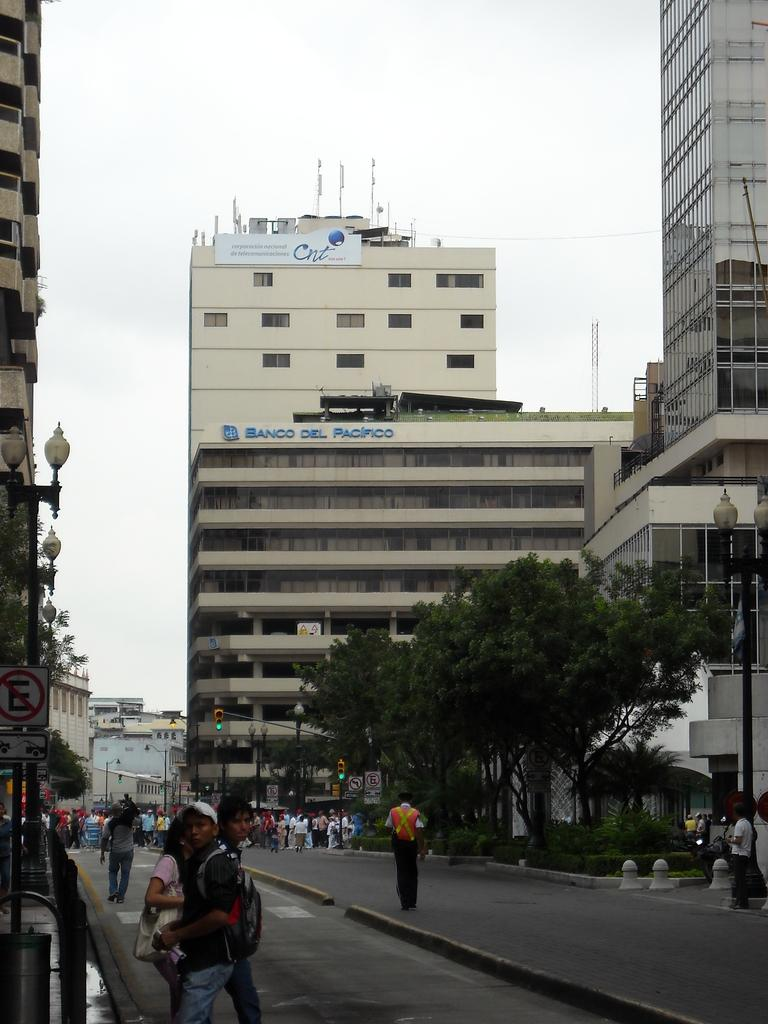<image>
Offer a succinct explanation of the picture presented. A number of buildings are in the background including the Banco Del Pacifico building. 